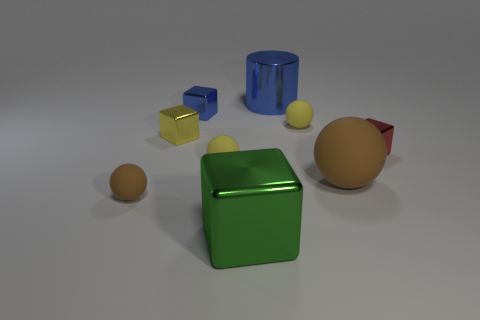Is there a tiny blue metal thing that has the same shape as the big rubber object? no 